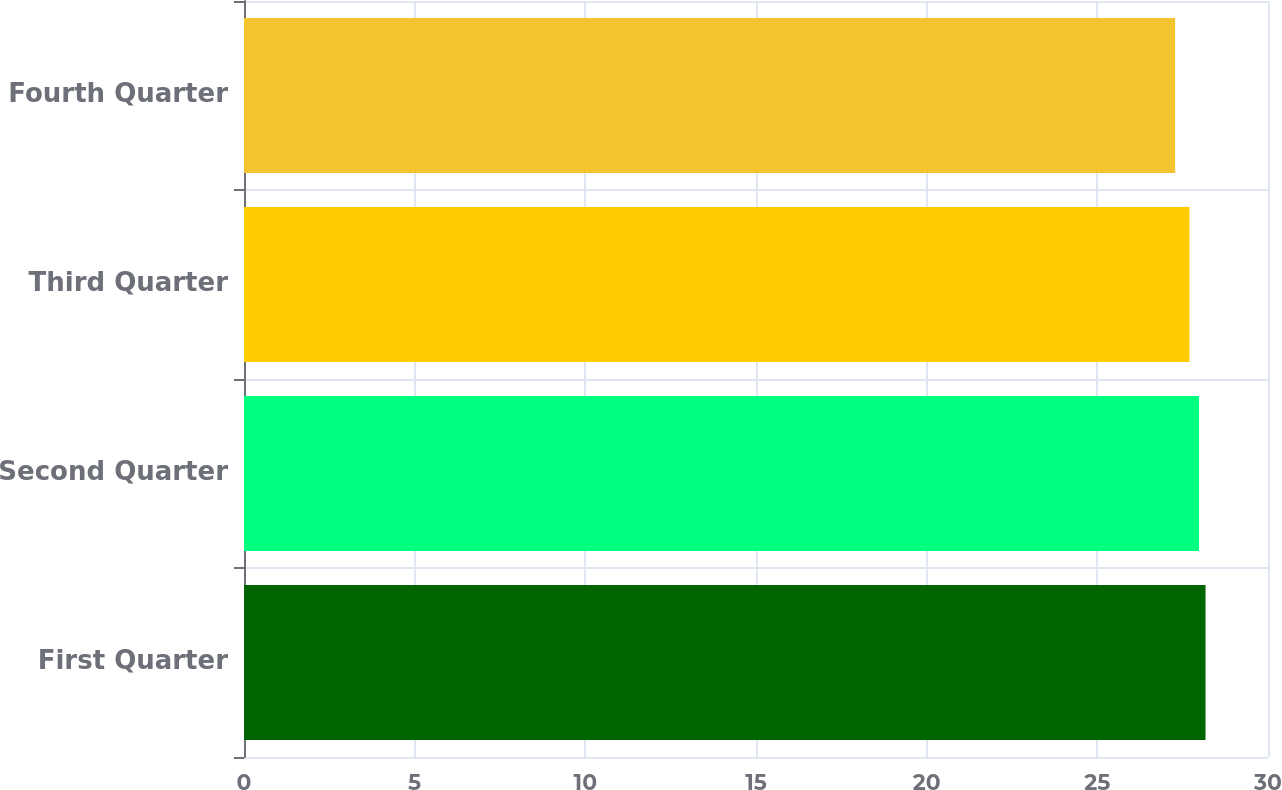Convert chart. <chart><loc_0><loc_0><loc_500><loc_500><bar_chart><fcel>First Quarter<fcel>Second Quarter<fcel>Third Quarter<fcel>Fourth Quarter<nl><fcel>28.17<fcel>27.98<fcel>27.7<fcel>27.28<nl></chart> 